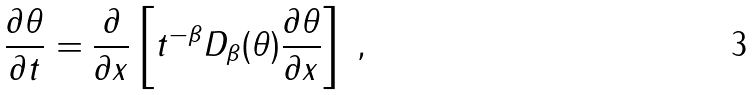<formula> <loc_0><loc_0><loc_500><loc_500>\frac { \partial \theta } { \partial t } = \frac { \partial } { \partial x } \left [ t ^ { - \beta } D _ { \beta } ( \theta ) \frac { \partial \theta } { \partial x } \right ] \text { ,}</formula> 